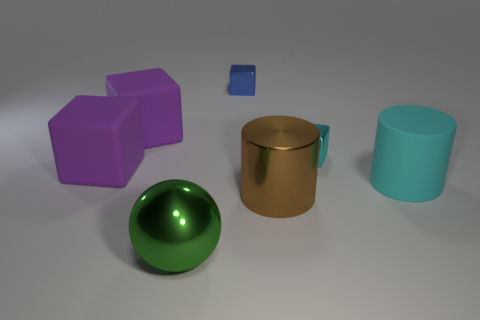Subtract 1 blocks. How many blocks are left? 3 Add 1 purple blocks. How many objects exist? 8 Subtract all cyan balls. Subtract all red cylinders. How many balls are left? 1 Subtract all balls. How many objects are left? 6 Add 5 big cyan rubber cylinders. How many big cyan rubber cylinders exist? 6 Subtract 0 gray spheres. How many objects are left? 7 Subtract all tiny objects. Subtract all shiny balls. How many objects are left? 4 Add 7 matte cubes. How many matte cubes are left? 9 